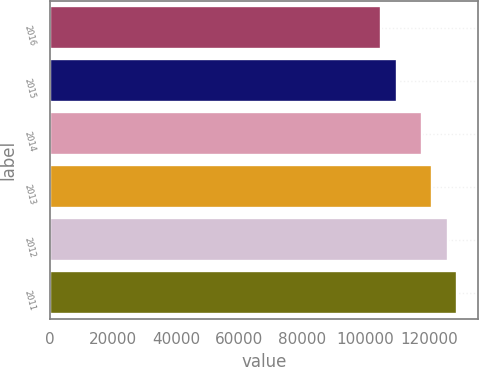Convert chart to OTSL. <chart><loc_0><loc_0><loc_500><loc_500><bar_chart><fcel>2016<fcel>2015<fcel>2014<fcel>2013<fcel>2012<fcel>2011<nl><fcel>105000<fcel>110000<fcel>118000<fcel>121000<fcel>126000<fcel>129000<nl></chart> 